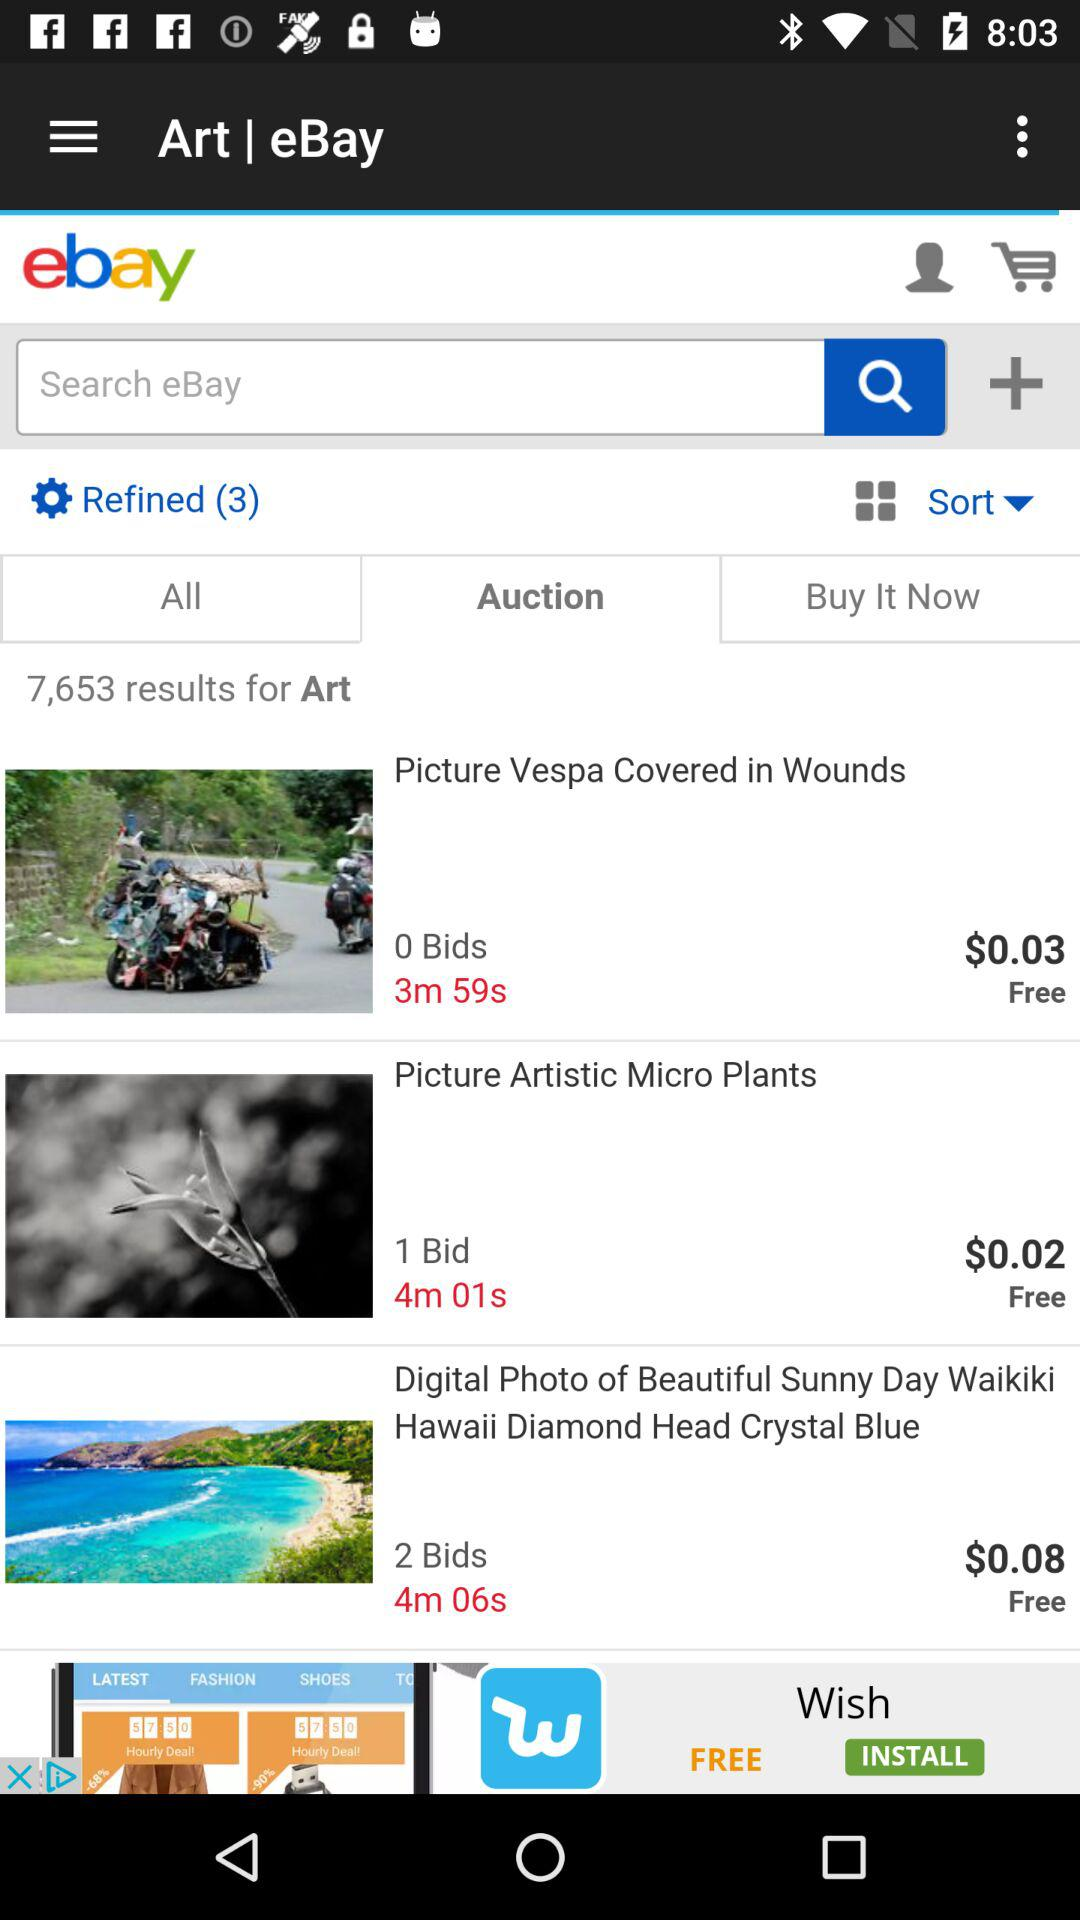How many results are there for Art?
Answer the question using a single word or phrase. 7,653 